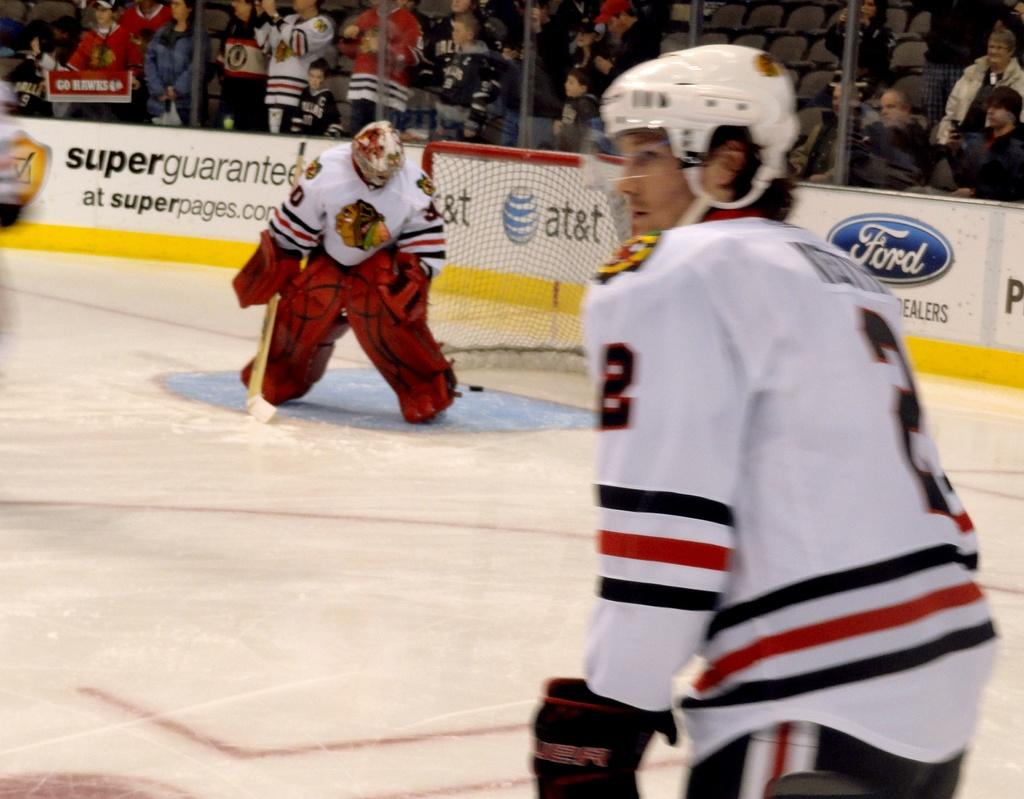How many people can be seen in the image? There are a few people in the image. What is visible beneath the people's feet? The ground is visible in the image. What are the boards with text used for in the image? The boards with text are likely used for communication or displaying information. What is the purpose of the net in the image? The net may be used for catching or containing objects, or it could be a part of a game or sport. What is the fence used for in the image? The fence may be used for marking boundaries, providing privacy, or ensuring safety. What type of seating is available in the image? There are a few chairs in the image. Can you see any balloons floating in the image? There are no balloons visible in the image. Is there any smoke coming from the chairs in the image? There is no smoke present in the image, and the chairs do not appear to be on fire or producing any smoke. 